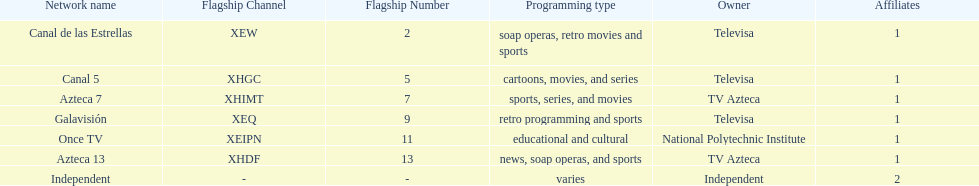What is the difference between the number of affiliates galavision has and the number of affiliates azteca 13 has? 0. 